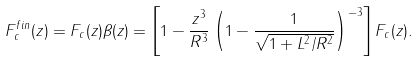<formula> <loc_0><loc_0><loc_500><loc_500>F _ { c } ^ { f i n } ( z ) = F _ { c } ( z ) \beta ( z ) = \left [ 1 - \frac { z ^ { 3 } } { R ^ { 3 } } \left ( 1 - \frac { 1 } { \sqrt { 1 + L ^ { 2 } / R ^ { 2 } } } \right ) ^ { - 3 } \right ] F _ { c } ( z ) .</formula> 